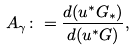<formula> <loc_0><loc_0><loc_500><loc_500>A _ { \gamma } \colon = \frac { d ( u ^ { * } G _ { * } ) } { d ( u ^ { * } G ) } ,</formula> 